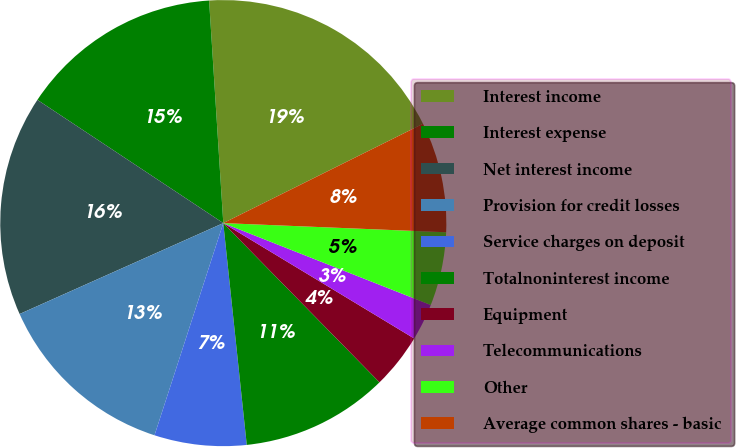<chart> <loc_0><loc_0><loc_500><loc_500><pie_chart><fcel>Interest income<fcel>Interest expense<fcel>Net interest income<fcel>Provision for credit losses<fcel>Service charges on deposit<fcel>Totalnoninterest income<fcel>Equipment<fcel>Telecommunications<fcel>Other<fcel>Average common shares - basic<nl><fcel>18.67%<fcel>14.67%<fcel>16.0%<fcel>13.33%<fcel>6.67%<fcel>10.67%<fcel>4.0%<fcel>2.67%<fcel>5.33%<fcel>8.0%<nl></chart> 